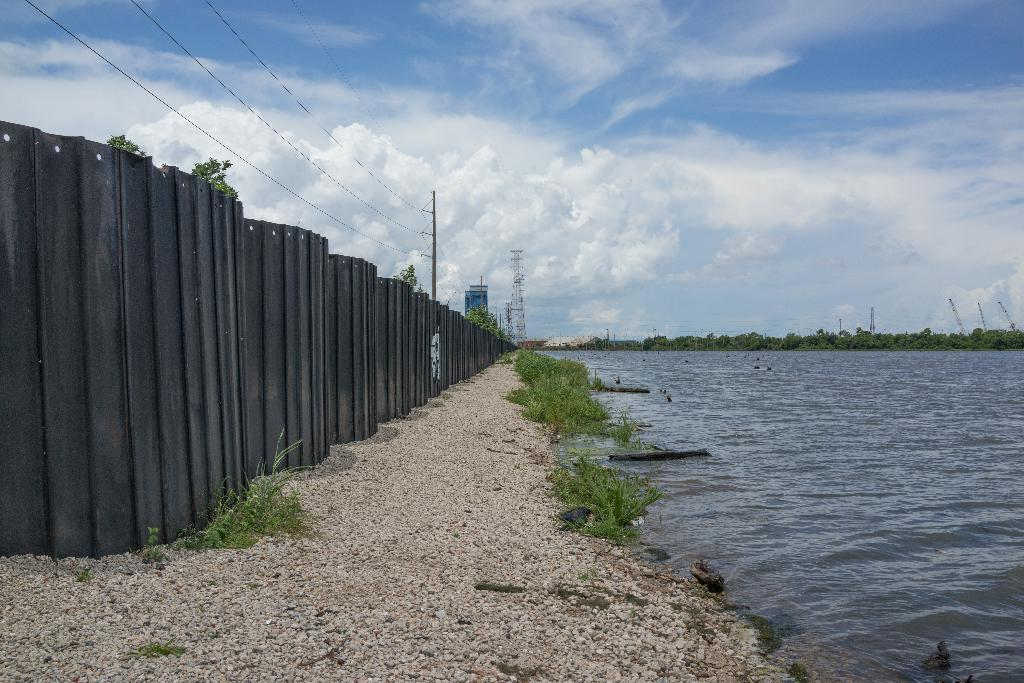What type of natural feature is present in the image? There is a river in the image. What can be seen in the background of the image? There are trees and towers in the background of the image. What is located on the left side of the image? There is a fencing tower pole and wires on the left side of the image. What is visible in the sky in the image? The sky is visible in the image. What type of coal is being mined in the image? There is no coal or mining activity present in the image. What type of rod is being used to catch fish in the river? There is no fishing rod or fishing activity present in the image. 